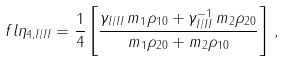Convert formula to latex. <formula><loc_0><loc_0><loc_500><loc_500>\ f l \eta _ { 4 , I / I I } = \frac { 1 } { 4 } \left [ \frac { \gamma _ { I / I I } \, m _ { 1 } \rho _ { 1 0 } + \gamma _ { I / I I } ^ { - 1 } \, m _ { 2 } \rho _ { 2 0 } } { m _ { 1 } \rho _ { 2 0 } + m _ { 2 } \rho _ { 1 0 } } \right ] \, ,</formula> 